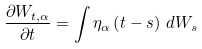<formula> <loc_0><loc_0><loc_500><loc_500>\frac { \partial W _ { t , \alpha } } { \partial t } = \int \eta _ { \alpha } \left ( t - s \right ) \, d W _ { s }</formula> 